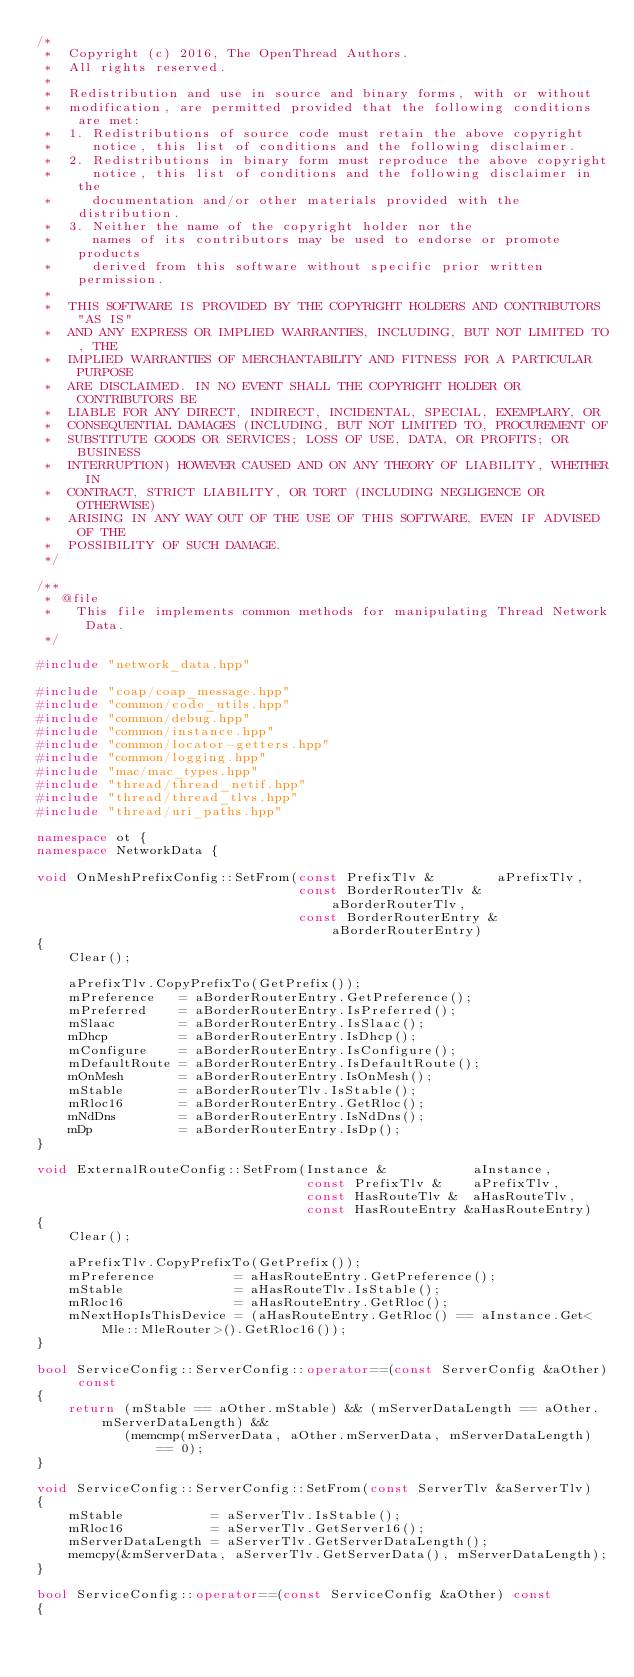<code> <loc_0><loc_0><loc_500><loc_500><_C++_>/*
 *  Copyright (c) 2016, The OpenThread Authors.
 *  All rights reserved.
 *
 *  Redistribution and use in source and binary forms, with or without
 *  modification, are permitted provided that the following conditions are met:
 *  1. Redistributions of source code must retain the above copyright
 *     notice, this list of conditions and the following disclaimer.
 *  2. Redistributions in binary form must reproduce the above copyright
 *     notice, this list of conditions and the following disclaimer in the
 *     documentation and/or other materials provided with the distribution.
 *  3. Neither the name of the copyright holder nor the
 *     names of its contributors may be used to endorse or promote products
 *     derived from this software without specific prior written permission.
 *
 *  THIS SOFTWARE IS PROVIDED BY THE COPYRIGHT HOLDERS AND CONTRIBUTORS "AS IS"
 *  AND ANY EXPRESS OR IMPLIED WARRANTIES, INCLUDING, BUT NOT LIMITED TO, THE
 *  IMPLIED WARRANTIES OF MERCHANTABILITY AND FITNESS FOR A PARTICULAR PURPOSE
 *  ARE DISCLAIMED. IN NO EVENT SHALL THE COPYRIGHT HOLDER OR CONTRIBUTORS BE
 *  LIABLE FOR ANY DIRECT, INDIRECT, INCIDENTAL, SPECIAL, EXEMPLARY, OR
 *  CONSEQUENTIAL DAMAGES (INCLUDING, BUT NOT LIMITED TO, PROCUREMENT OF
 *  SUBSTITUTE GOODS OR SERVICES; LOSS OF USE, DATA, OR PROFITS; OR BUSINESS
 *  INTERRUPTION) HOWEVER CAUSED AND ON ANY THEORY OF LIABILITY, WHETHER IN
 *  CONTRACT, STRICT LIABILITY, OR TORT (INCLUDING NEGLIGENCE OR OTHERWISE)
 *  ARISING IN ANY WAY OUT OF THE USE OF THIS SOFTWARE, EVEN IF ADVISED OF THE
 *  POSSIBILITY OF SUCH DAMAGE.
 */

/**
 * @file
 *   This file implements common methods for manipulating Thread Network Data.
 */

#include "network_data.hpp"

#include "coap/coap_message.hpp"
#include "common/code_utils.hpp"
#include "common/debug.hpp"
#include "common/instance.hpp"
#include "common/locator-getters.hpp"
#include "common/logging.hpp"
#include "mac/mac_types.hpp"
#include "thread/thread_netif.hpp"
#include "thread/thread_tlvs.hpp"
#include "thread/uri_paths.hpp"

namespace ot {
namespace NetworkData {

void OnMeshPrefixConfig::SetFrom(const PrefixTlv &        aPrefixTlv,
                                 const BorderRouterTlv &  aBorderRouterTlv,
                                 const BorderRouterEntry &aBorderRouterEntry)
{
    Clear();

    aPrefixTlv.CopyPrefixTo(GetPrefix());
    mPreference   = aBorderRouterEntry.GetPreference();
    mPreferred    = aBorderRouterEntry.IsPreferred();
    mSlaac        = aBorderRouterEntry.IsSlaac();
    mDhcp         = aBorderRouterEntry.IsDhcp();
    mConfigure    = aBorderRouterEntry.IsConfigure();
    mDefaultRoute = aBorderRouterEntry.IsDefaultRoute();
    mOnMesh       = aBorderRouterEntry.IsOnMesh();
    mStable       = aBorderRouterTlv.IsStable();
    mRloc16       = aBorderRouterEntry.GetRloc();
    mNdDns        = aBorderRouterEntry.IsNdDns();
    mDp           = aBorderRouterEntry.IsDp();
}

void ExternalRouteConfig::SetFrom(Instance &           aInstance,
                                  const PrefixTlv &    aPrefixTlv,
                                  const HasRouteTlv &  aHasRouteTlv,
                                  const HasRouteEntry &aHasRouteEntry)
{
    Clear();

    aPrefixTlv.CopyPrefixTo(GetPrefix());
    mPreference          = aHasRouteEntry.GetPreference();
    mStable              = aHasRouteTlv.IsStable();
    mRloc16              = aHasRouteEntry.GetRloc();
    mNextHopIsThisDevice = (aHasRouteEntry.GetRloc() == aInstance.Get<Mle::MleRouter>().GetRloc16());
}

bool ServiceConfig::ServerConfig::operator==(const ServerConfig &aOther) const
{
    return (mStable == aOther.mStable) && (mServerDataLength == aOther.mServerDataLength) &&
           (memcmp(mServerData, aOther.mServerData, mServerDataLength) == 0);
}

void ServiceConfig::ServerConfig::SetFrom(const ServerTlv &aServerTlv)
{
    mStable           = aServerTlv.IsStable();
    mRloc16           = aServerTlv.GetServer16();
    mServerDataLength = aServerTlv.GetServerDataLength();
    memcpy(&mServerData, aServerTlv.GetServerData(), mServerDataLength);
}

bool ServiceConfig::operator==(const ServiceConfig &aOther) const
{</code> 